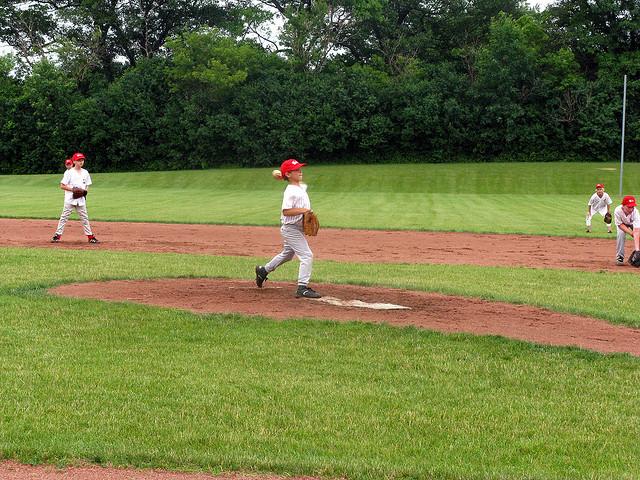What field is the team playing at?
Concise answer only. Baseball. Is the boy catching the ball?
Write a very short answer. No. What color are the caps the boys are wearing?
Keep it brief. Red. What is on the field?
Short answer required. Grass. What hand is the kid with the black glove planning to catch with?
Be succinct. Left. Did the pitcher throw the ball?
Keep it brief. No. 